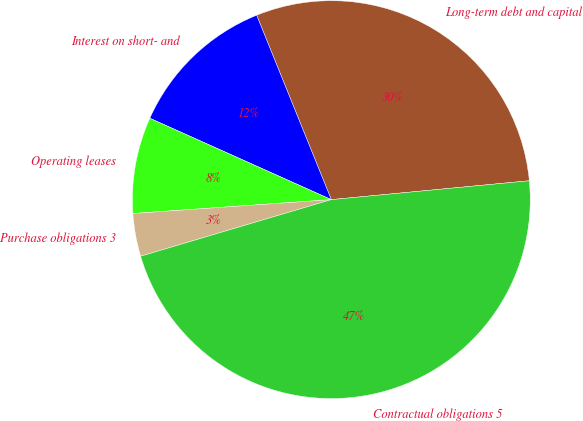<chart> <loc_0><loc_0><loc_500><loc_500><pie_chart><fcel>Long-term debt and capital<fcel>Interest on short- and<fcel>Operating leases<fcel>Purchase obligations 3<fcel>Contractual obligations 5<nl><fcel>29.61%<fcel>12.17%<fcel>7.82%<fcel>3.48%<fcel>46.92%<nl></chart> 